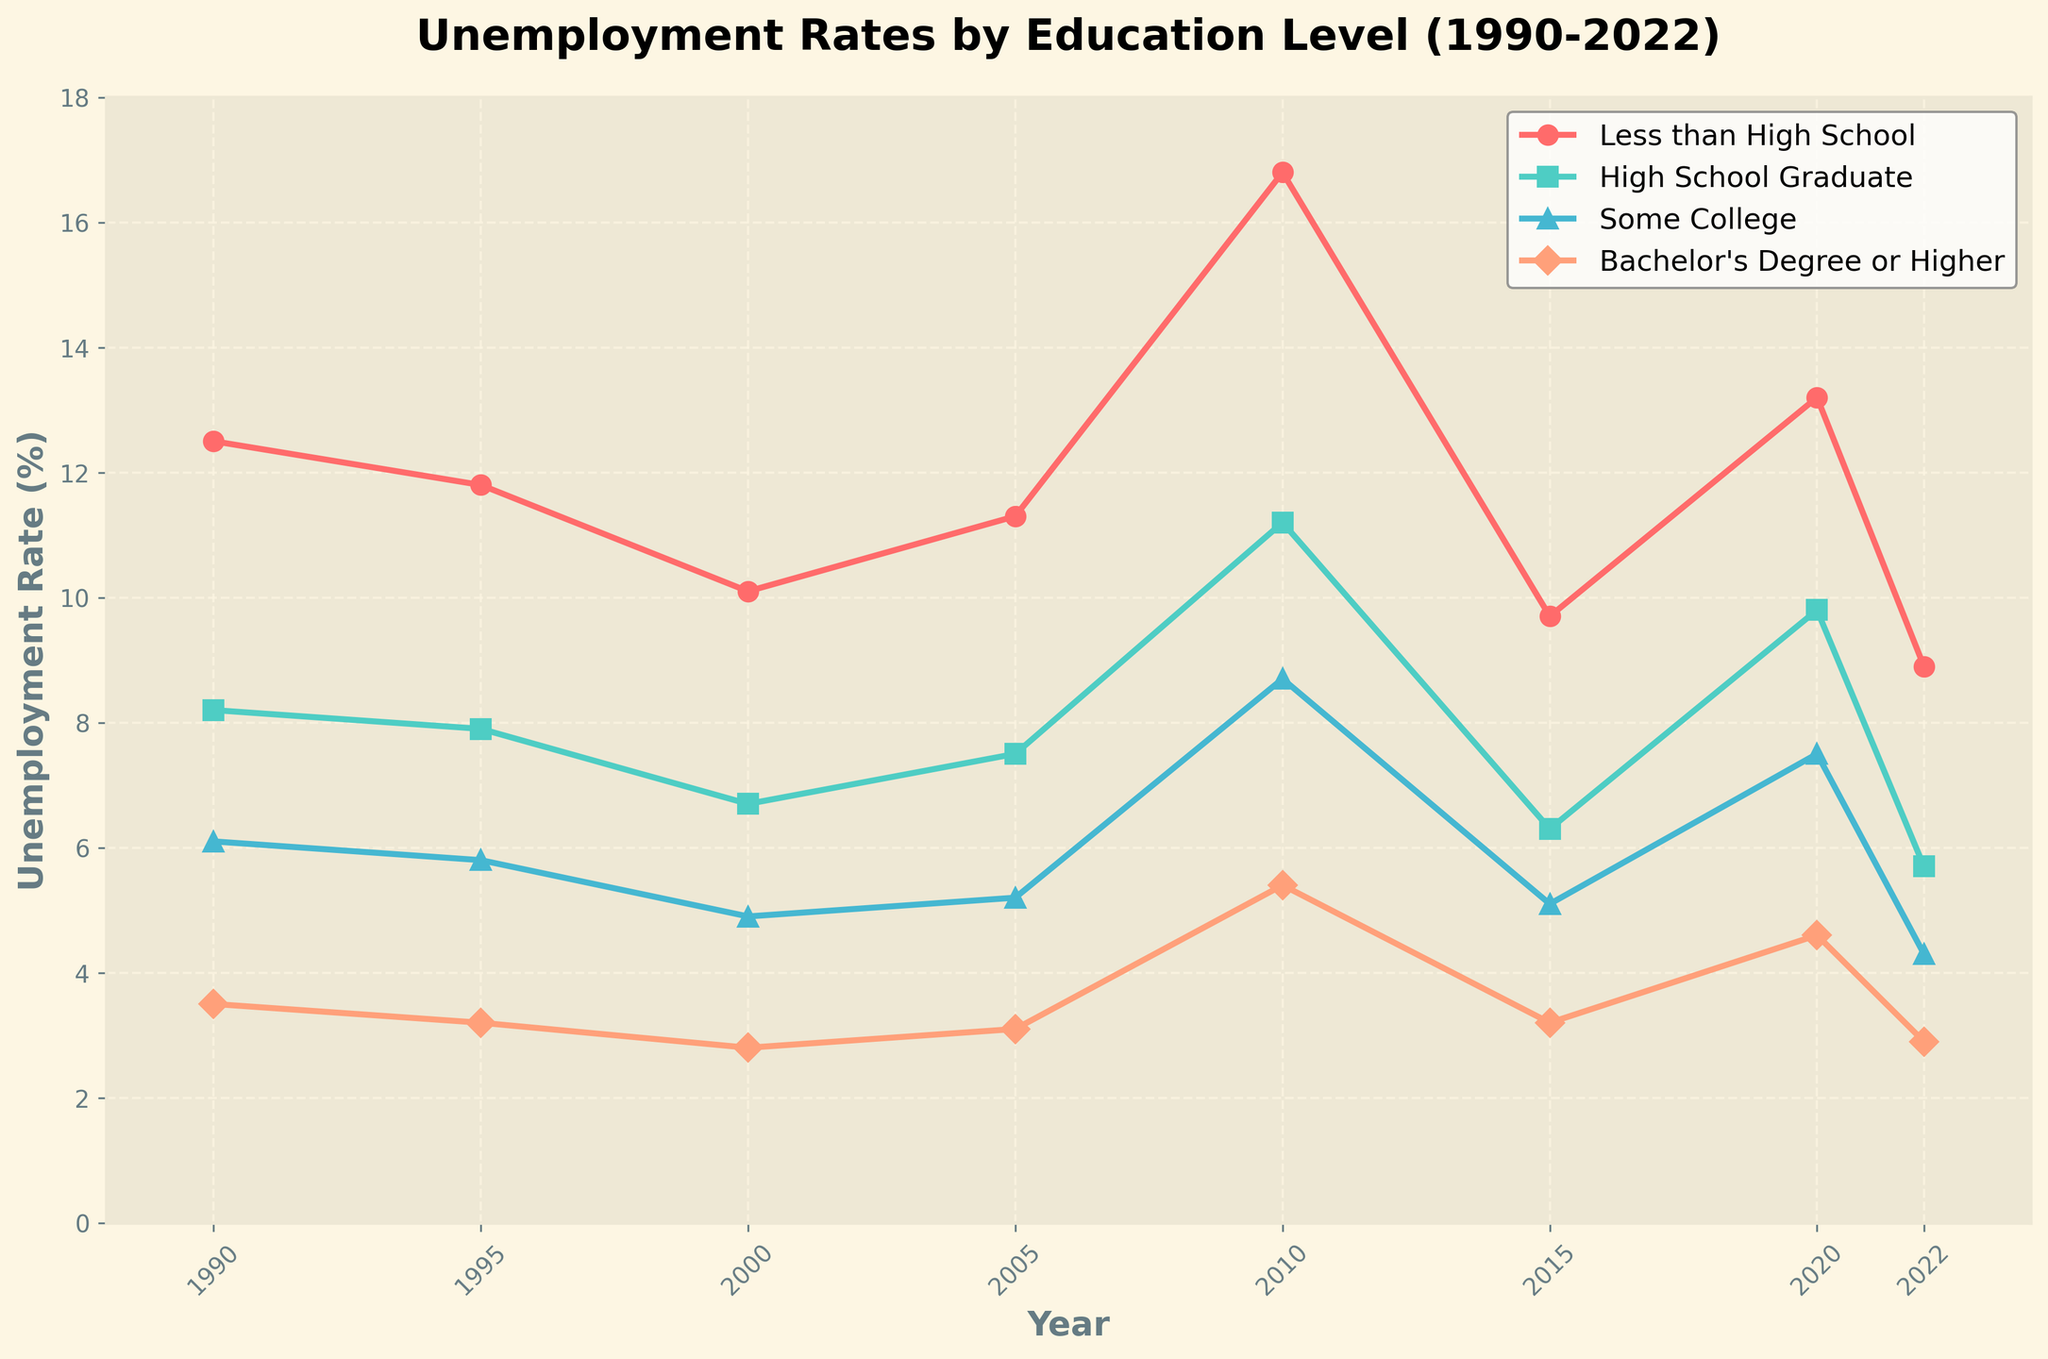How did the unemployment rate for those with less than a high school diploma change from 1990 to 2022? Look at the starting value for 1990 and the ending value for 2022 for the "Less than High School" line, noting the decrease over time from 12.5% to 8.9%.
Answer: Decreased by 3.6% Which education level had the highest unemployment rate in 2010? Identify the highest point among all lines in the year 2010; "Less than High School" has the highest rate at 16.8%.
Answer: Less than High School Between 1990 and 2022, which education level saw the greatest overall decline in unemployment rate? Calculate the absolute difference between 1990 and 2022 for each education level:  
Less than High School: 12.5% - 8.9% = 3.6%  
High School Graduate: 8.2% - 5.7% = 2.5%  
Some College: 6.1% - 4.3% = 1.8%  
Bachelor's Degree or Higher: 3.5% - 2.9% = 0.6%  
The greatest decline is for "Less than High School" at 3.6%.
Answer: Less than High School In which year did the unemployment rate for "Some College" surpass 5%? Trace the line for "Some College" and see it surpasses 5% starting in 2010 (8.7%).
Answer: 2010 Which year experienced the highest peak in unemployment rates across all education levels? Compare the peak values in each line across all years; 2010 shows the highest peaks for almost all education levels, with "Less than High School" reaching 16.8%.
Answer: 2010 How did the unemployment rate for "Bachelor's Degree or Higher" change from 2000 to 2020? Note the 2000 value (2.8%) and the 2020 value (4.6%), indicating an increase. First, subtract the 2000 rate from the 2020 rate, 4.6% - 2.8%, resulting in an increase of 1.8%.
Answer: Increased by 1.8% By how much did the unemployment rate for "High School Graduate" decrease from 2010 to 2022? Find the difference between the unemployment rates in these years: 2010 (11.2%) and 2022 (5.7%); subtract 2022 rate from 2010 rate, 11.2% - 5.7% = 5.5%.
Answer: Decreased by 5.5% Which education levels had unemployment rates below 5% in the most recent year shown? Look at the 2022 values and identify the education levels with unemployment rates below 5%: None except "Bachelor's Degree or Higher" at 2.9%.
Answer: Bachelor's Degree or Higher What is the average unemployment rate for "Some College" over the period from 1990 to 2022? Sum the values and divide by the number of years:
(6.1 + 5.8 + 4.9 + 5.2 + 8.7 + 5.1 + 7.5 + 4.3) / 8 = 5.825%
Answer: 5.825% Compare the unemployment trends for "High School Graduate" and "Bachelor's Degree or Higher." Observe the line plot trends over the years:
- "High School Graduate" shows a generally decreasing trend with peaks around 2005 and 2010.
- "Bachelor's Degree or Higher" is consistently the lowest and shows smaller fluctuations.
Answer: High School Graduate has larger fluctuations; Bachelor's Degree or Higher is more stable 